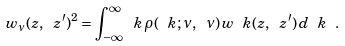<formula> <loc_0><loc_0><loc_500><loc_500>w _ { \nu } ( z , \ z ^ { \prime } ) ^ { 2 } = \int _ { - \infty } ^ { \infty } \ k \, \rho ( \ k ; \nu , \ \nu ) \, w _ { \ } k ( z , \ z ^ { \prime } ) \, d \ k \ .</formula> 